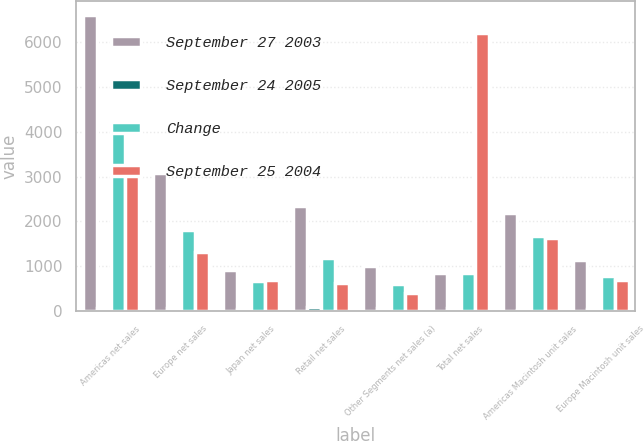Convert chart. <chart><loc_0><loc_0><loc_500><loc_500><stacked_bar_chart><ecel><fcel>Americas net sales<fcel>Europe net sales<fcel>Japan net sales<fcel>Retail net sales<fcel>Other Segments net sales (a)<fcel>Total net sales<fcel>Americas Macintosh unit sales<fcel>Europe Macintosh unit sales<nl><fcel>September 27 2003<fcel>6590<fcel>3073<fcel>920<fcel>2350<fcel>998<fcel>846.5<fcel>2184<fcel>1138<nl><fcel>September 24 2005<fcel>64<fcel>71<fcel>36<fcel>98<fcel>67<fcel>68<fcel>30<fcel>47<nl><fcel>Change<fcel>4019<fcel>1799<fcel>677<fcel>1185<fcel>599<fcel>846.5<fcel>1682<fcel>773<nl><fcel>September 25 2004<fcel>3181<fcel>1309<fcel>698<fcel>621<fcel>398<fcel>6207<fcel>1620<fcel>684<nl></chart> 